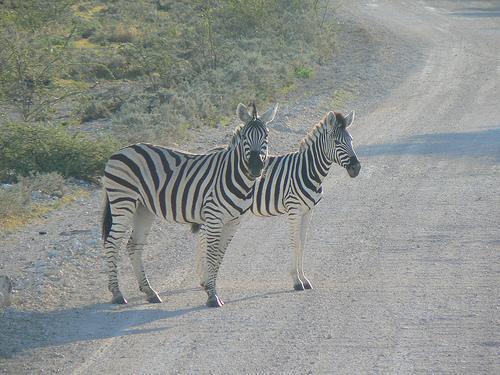How many zebras are there?
Give a very brief answer. 2. 